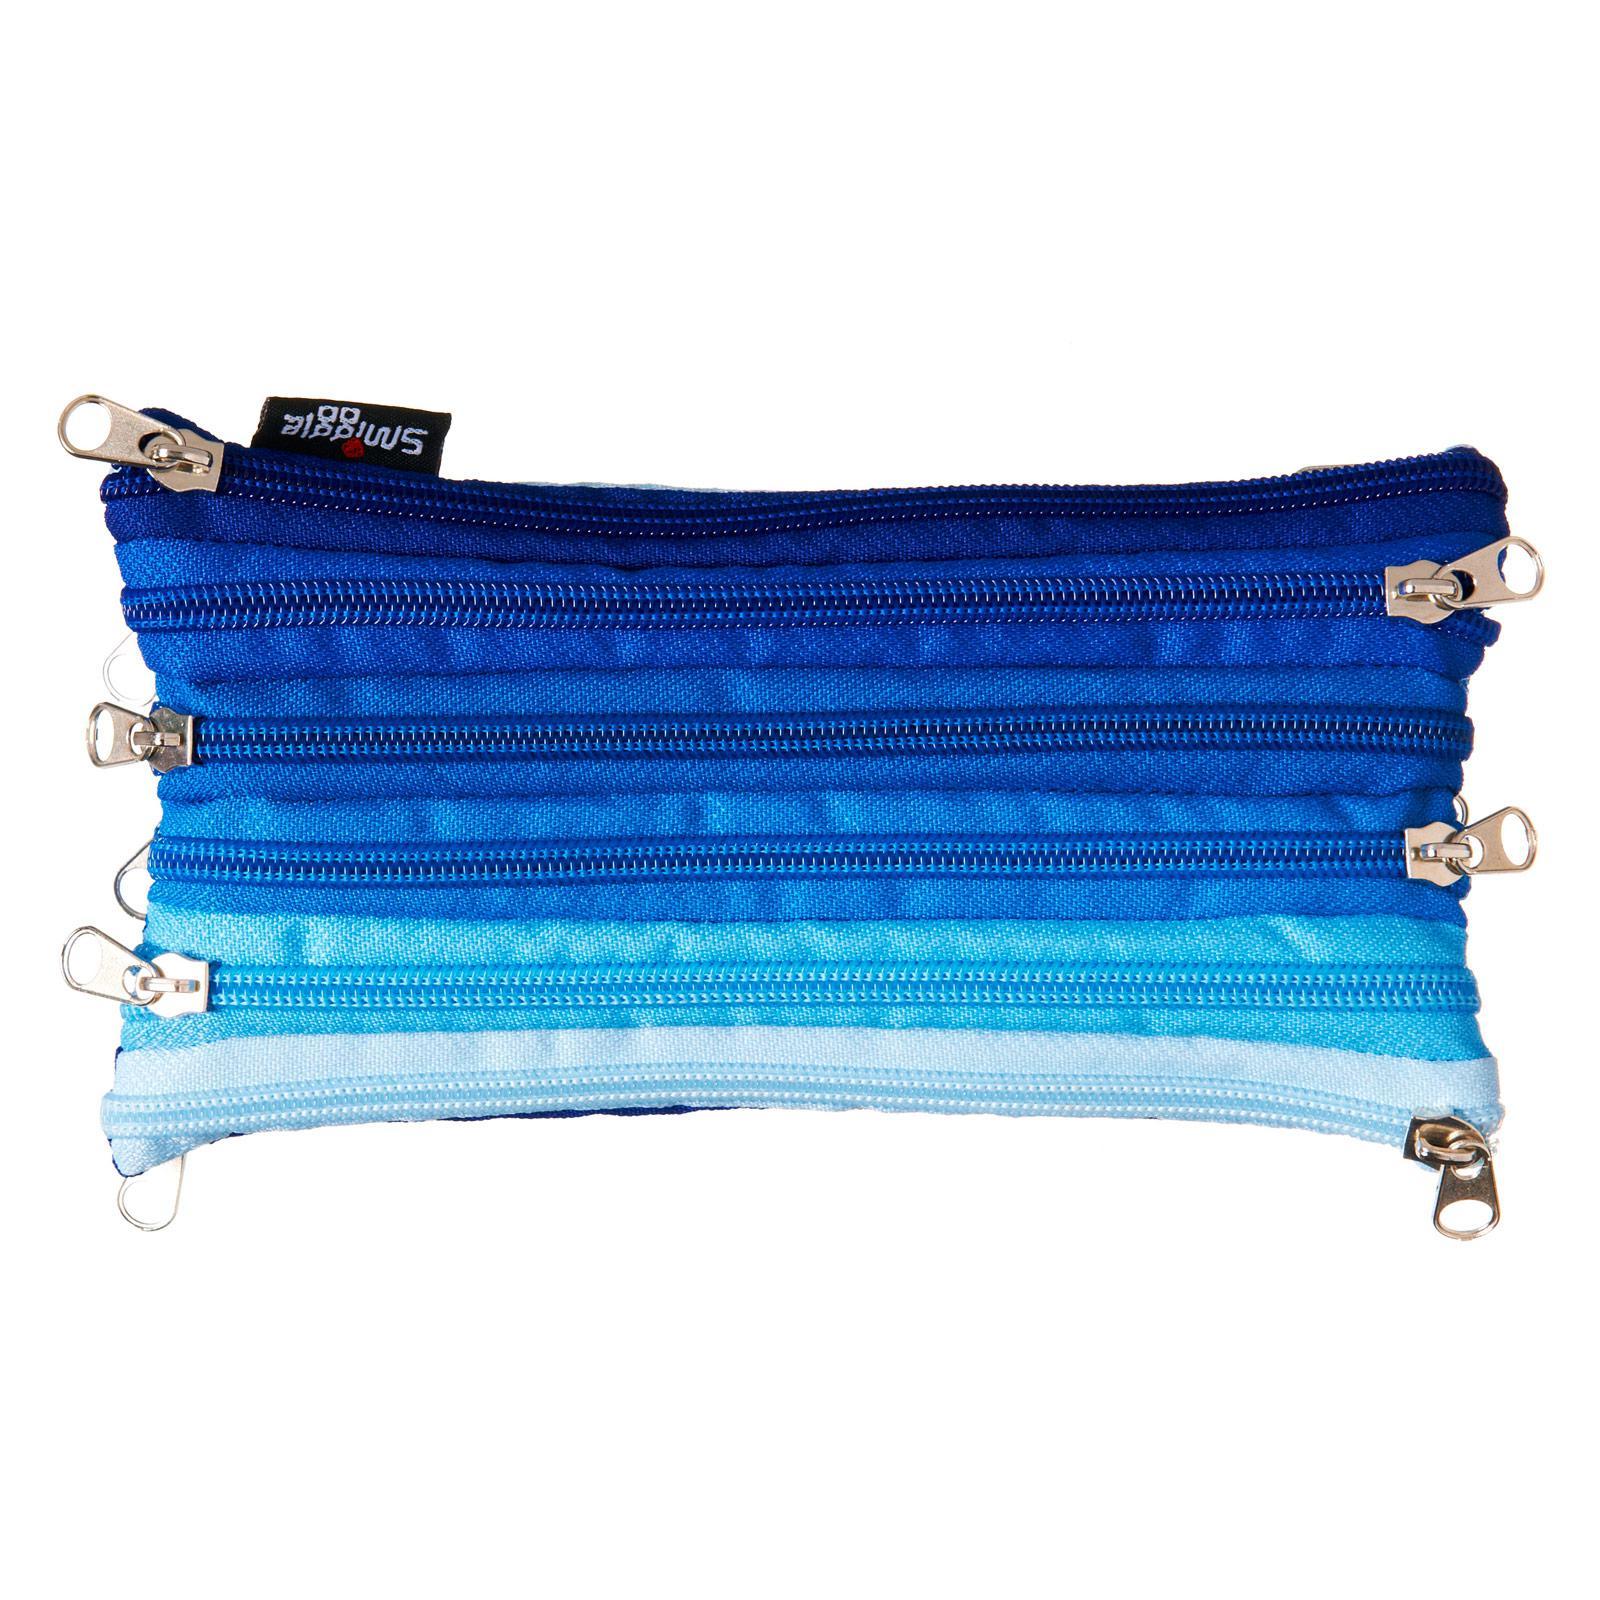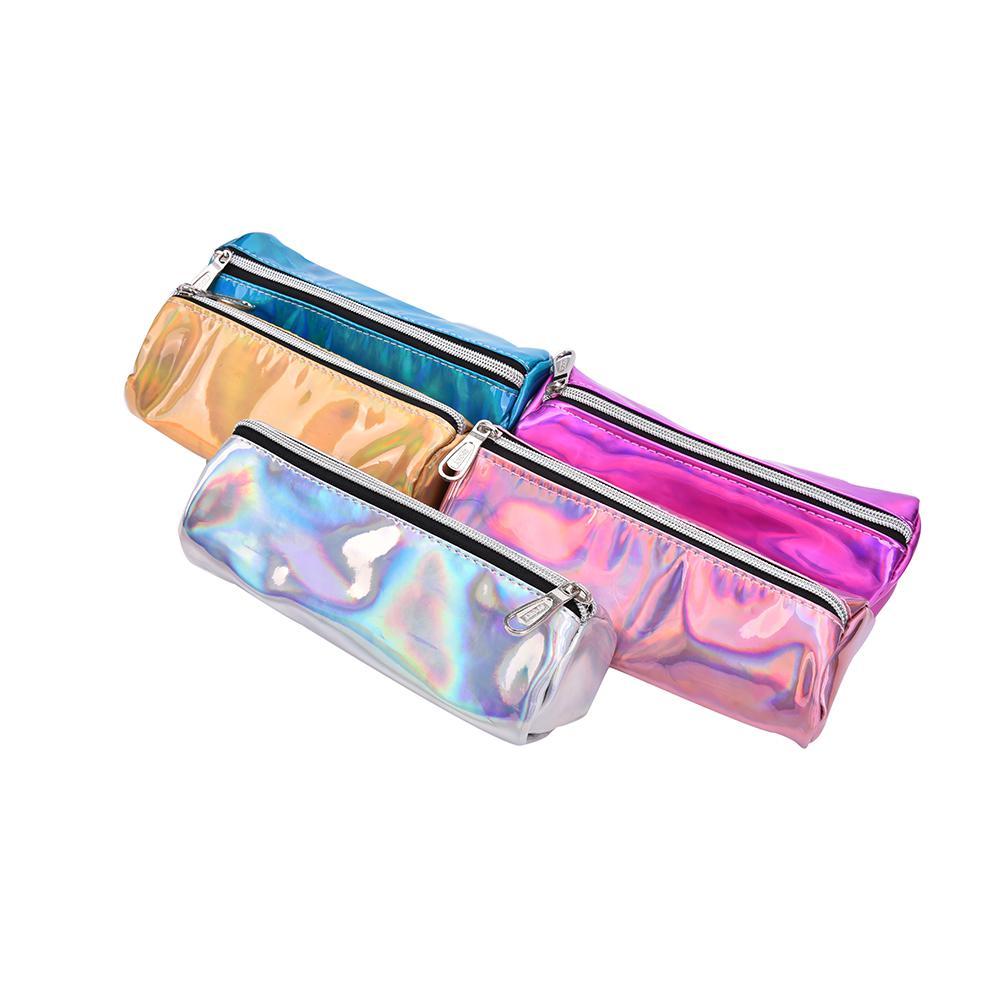The first image is the image on the left, the second image is the image on the right. Assess this claim about the two images: "The pair of images contain nearly identical items, with the same colors.". Correct or not? Answer yes or no. No. 